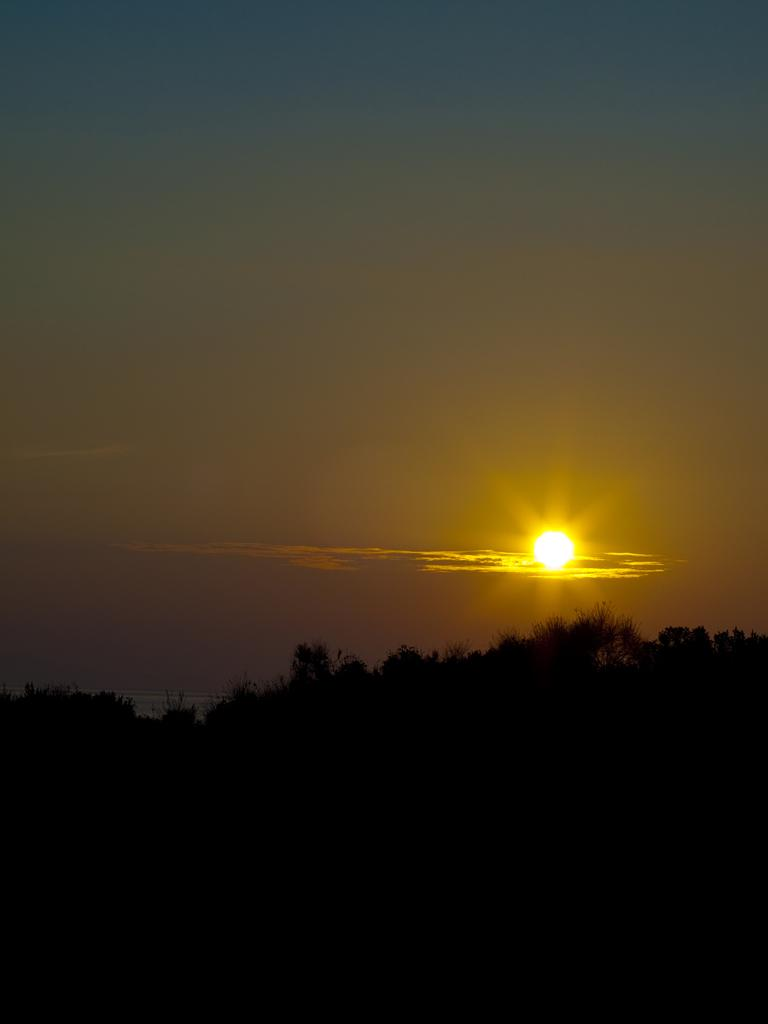What can be seen in the sky in the image? The sun is visible in the image. What type of natural elements are present in the image? There are plants in the image. How would you describe the bottom part of the image? The bottom of the image has a dark view. Can you see a kitten playing volleyball with a hat in the image? There is no kitten, volleyball, or hat present in the image. 